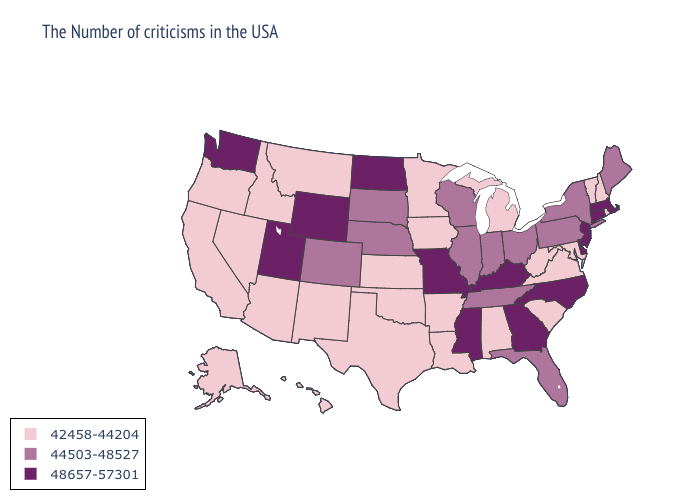Which states have the lowest value in the USA?
Give a very brief answer. Rhode Island, New Hampshire, Vermont, Maryland, Virginia, South Carolina, West Virginia, Michigan, Alabama, Louisiana, Arkansas, Minnesota, Iowa, Kansas, Oklahoma, Texas, New Mexico, Montana, Arizona, Idaho, Nevada, California, Oregon, Alaska, Hawaii. What is the value of North Dakota?
Quick response, please. 48657-57301. Does Kentucky have the lowest value in the South?
Short answer required. No. Does the map have missing data?
Be succinct. No. Does the map have missing data?
Be succinct. No. What is the value of Mississippi?
Concise answer only. 48657-57301. Does Alaska have a lower value than Tennessee?
Write a very short answer. Yes. What is the value of Arizona?
Quick response, please. 42458-44204. What is the value of Hawaii?
Answer briefly. 42458-44204. Does Louisiana have a lower value than Maryland?
Keep it brief. No. What is the value of Florida?
Write a very short answer. 44503-48527. What is the value of Pennsylvania?
Write a very short answer. 44503-48527. Name the states that have a value in the range 44503-48527?
Concise answer only. Maine, New York, Pennsylvania, Ohio, Florida, Indiana, Tennessee, Wisconsin, Illinois, Nebraska, South Dakota, Colorado. 